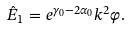Convert formula to latex. <formula><loc_0><loc_0><loc_500><loc_500>\hat { E } _ { 1 } = e ^ { \gamma _ { 0 } - 2 \alpha _ { 0 } } k ^ { 2 } \varphi .</formula> 